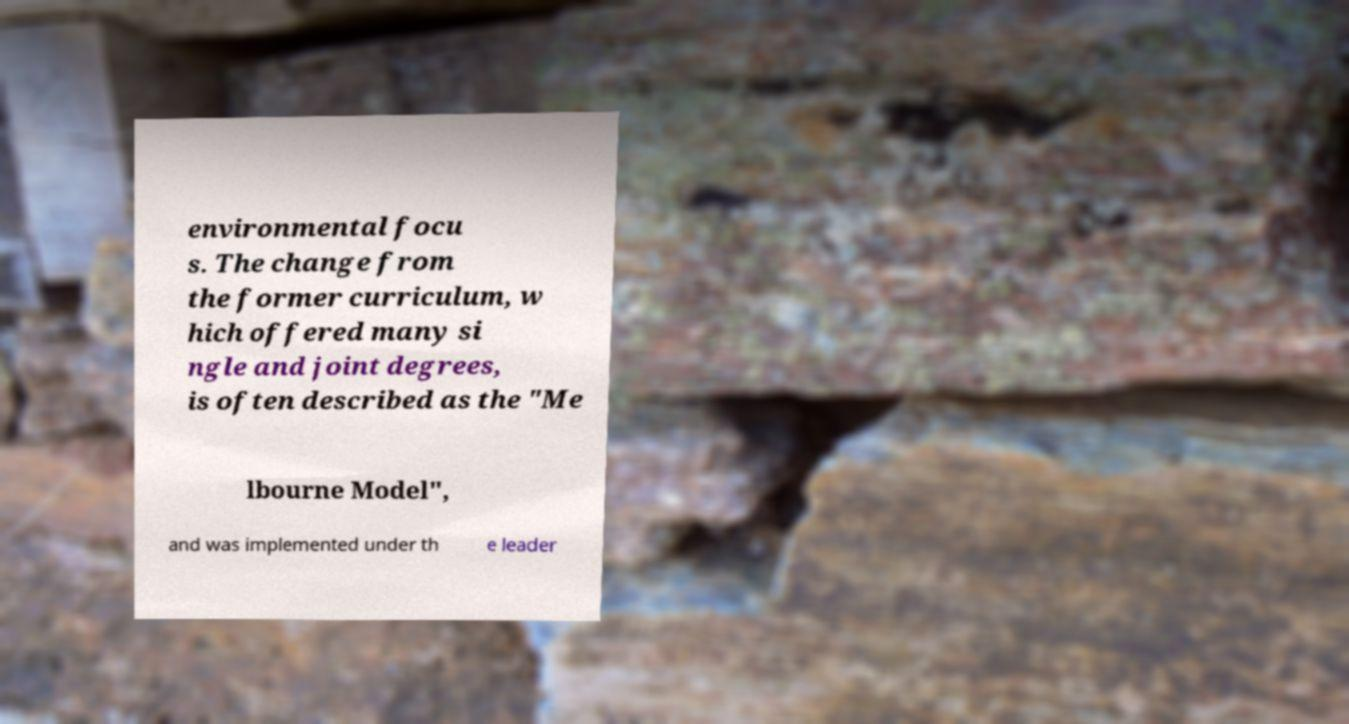There's text embedded in this image that I need extracted. Can you transcribe it verbatim? environmental focu s. The change from the former curriculum, w hich offered many si ngle and joint degrees, is often described as the "Me lbourne Model", and was implemented under th e leader 